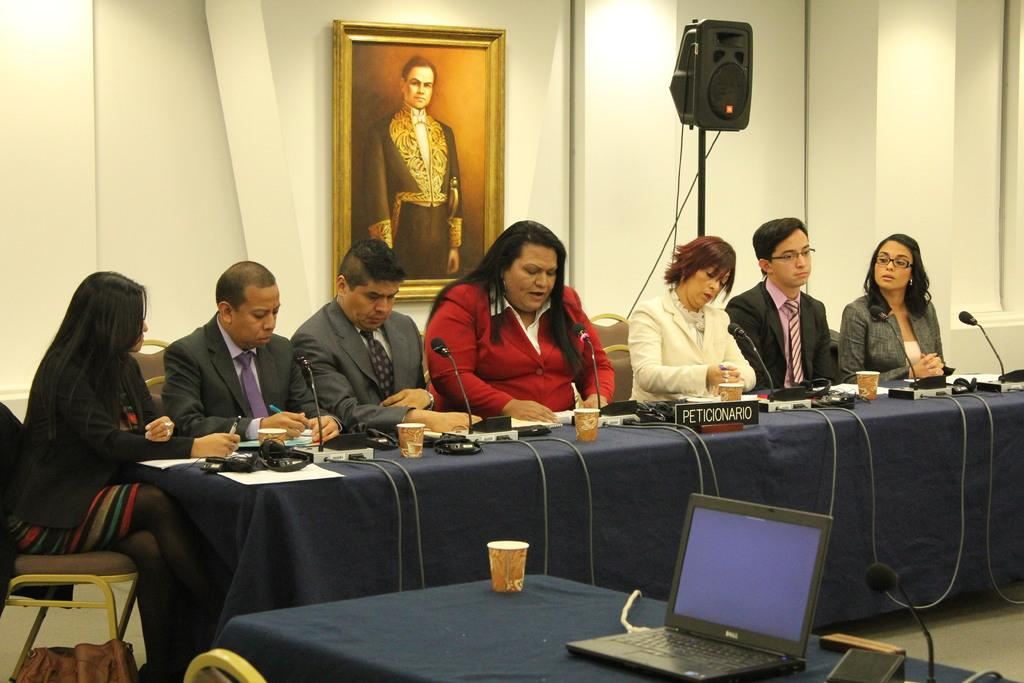<image>
Give a short and clear explanation of the subsequent image. A Dell branded laptop is sitting on a table with a group of people sitting on another table. 